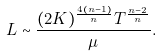Convert formula to latex. <formula><loc_0><loc_0><loc_500><loc_500>L \sim \frac { ( 2 K ) ^ { \frac { 4 ( n - 1 ) } { n } } T ^ { \frac { n - 2 } { n } } } { \mu } .</formula> 